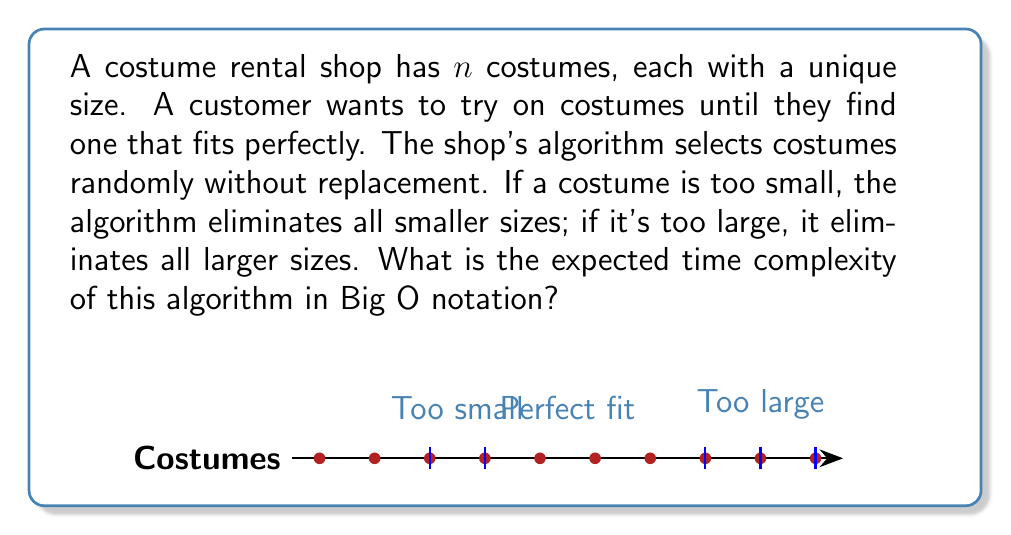Can you solve this math problem? Let's analyze this algorithm step-by-step:

1) The algorithm uses a binary search approach, eliminating half of the remaining costumes on average with each try.

2) In the worst case, we start with $n$ costumes and keep dividing by 2 until we reach 1:

   $$n \rightarrow \frac{n}{2} \rightarrow \frac{n}{4} \rightarrow ... \rightarrow 1$$

3) The number of steps in this process is equal to $k$ where:

   $$\frac{n}{2^k} = 1$$

4) Solving for $k$:

   $$n = 2^k$$
   $$\log_2(n) = k$$

5) Therefore, the number of costume tries is logarithmic in $n$.

6) Each try involves a random selection, which can be done in $O(1)$ time with proper data structures.

7) The elimination of costumes after each try can be done in $O(1)$ time if we use appropriate data structures (e.g., two heaps).

8) Thus, each iteration takes $O(1)$ time, and we have $O(\log n)$ iterations.

9) The overall time complexity is therefore $O(\log n)$.
Answer: $O(\log n)$ 